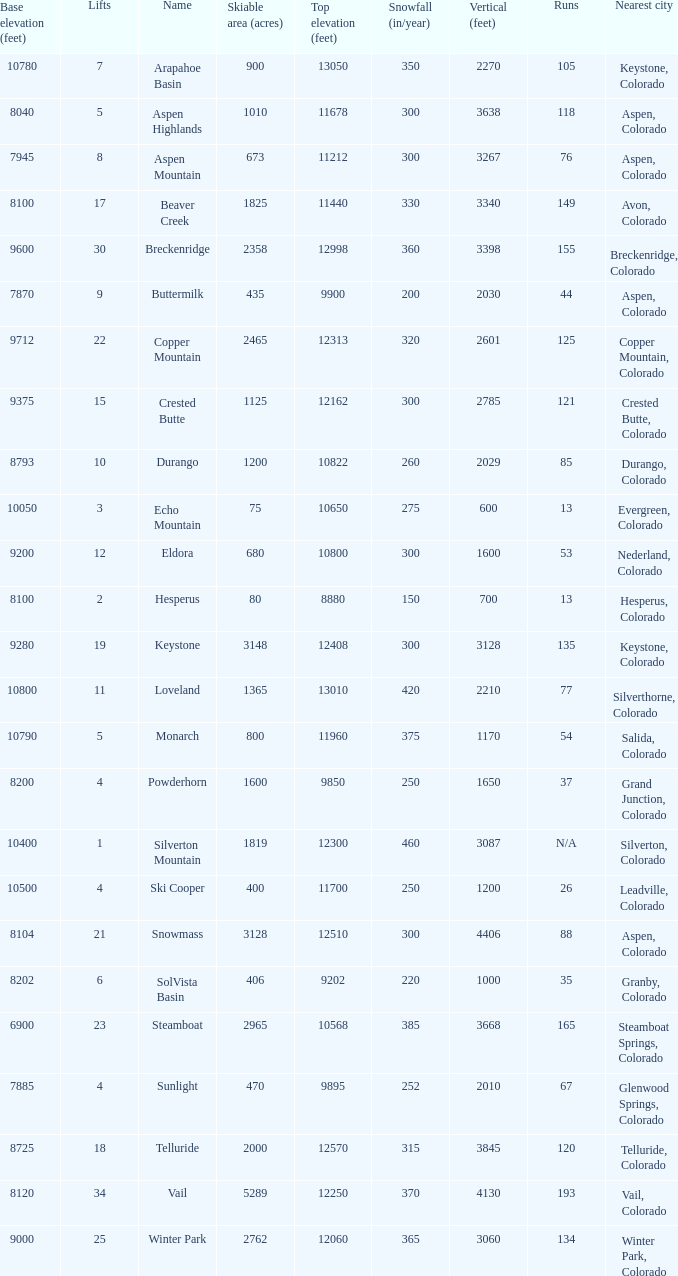What is the snowfall for ski resort Snowmass? 300.0. 